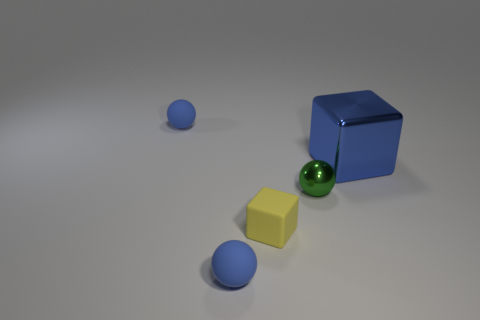Is there anything else that has the same size as the shiny block?
Offer a very short reply. No. What is the color of the tiny rubber sphere that is behind the blue matte object that is in front of the tiny blue sphere behind the small green shiny thing?
Ensure brevity in your answer.  Blue. There is a metallic cube on the right side of the matte ball that is in front of the small block; what size is it?
Offer a very short reply. Large. What is the object that is both to the right of the tiny yellow matte object and to the left of the large blue object made of?
Make the answer very short. Metal. Does the green sphere have the same size as the block that is behind the small green sphere?
Provide a succinct answer. No. Is there a large yellow metallic sphere?
Your response must be concise. No. There is another object that is the same shape as the tiny yellow matte object; what is it made of?
Keep it short and to the point. Metal. How big is the blue object that is on the right side of the small blue matte thing that is in front of the matte ball behind the yellow cube?
Your answer should be very brief. Large. There is a big blue metal thing; are there any tiny matte spheres behind it?
Ensure brevity in your answer.  Yes. What size is the blue cube that is made of the same material as the small green thing?
Provide a succinct answer. Large. 